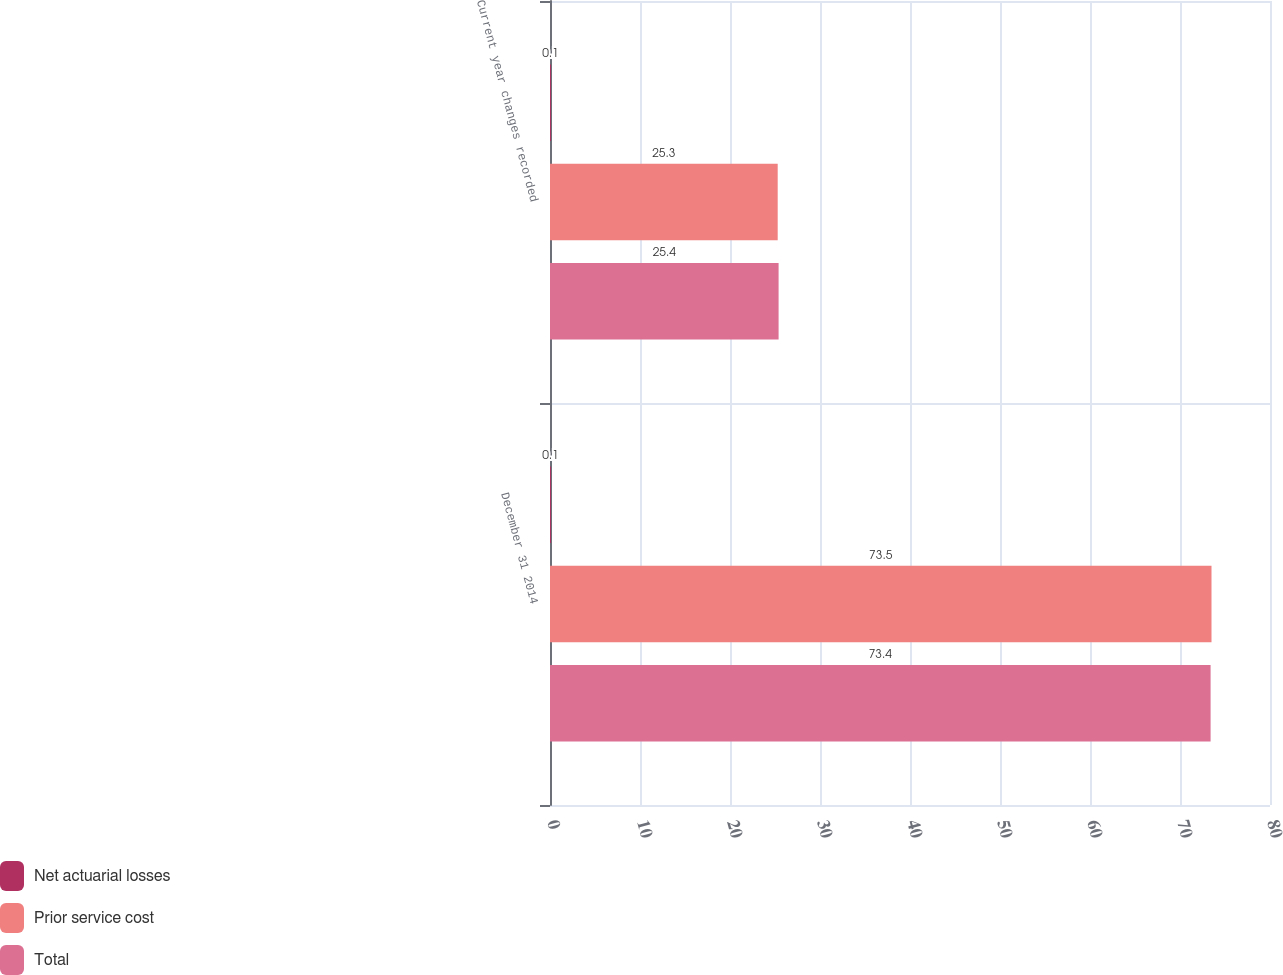Convert chart to OTSL. <chart><loc_0><loc_0><loc_500><loc_500><stacked_bar_chart><ecel><fcel>December 31 2014<fcel>Current year changes recorded<nl><fcel>Net actuarial losses<fcel>0.1<fcel>0.1<nl><fcel>Prior service cost<fcel>73.5<fcel>25.3<nl><fcel>Total<fcel>73.4<fcel>25.4<nl></chart> 